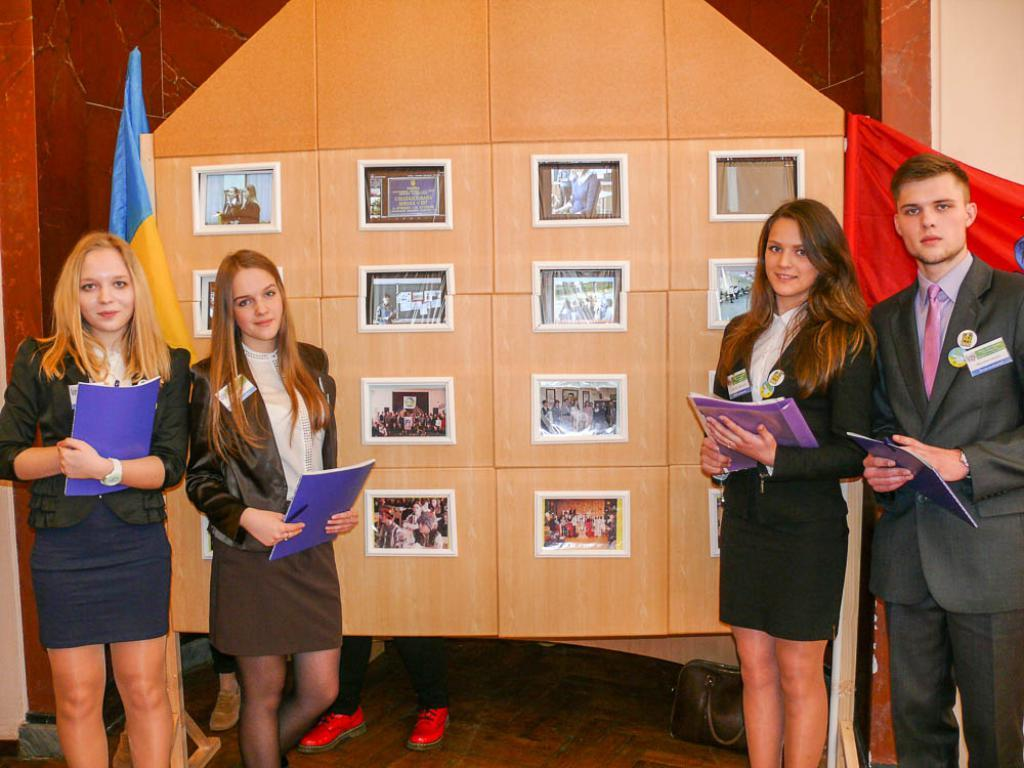Who or what is present in the image? There are people in the image. What are some of the people holding? Some of the people are holding files. What can be seen on the wall in the image? There are photo frames on the wall. What is the flag associated with in the image? The flag is present in the image. What type of object can be seen in the image that might be used for carrying items? There is a bag in the image. How does the heat affect the people in the image? There is no indication of heat or temperature in the image, so it cannot be determined how it affects the people. 